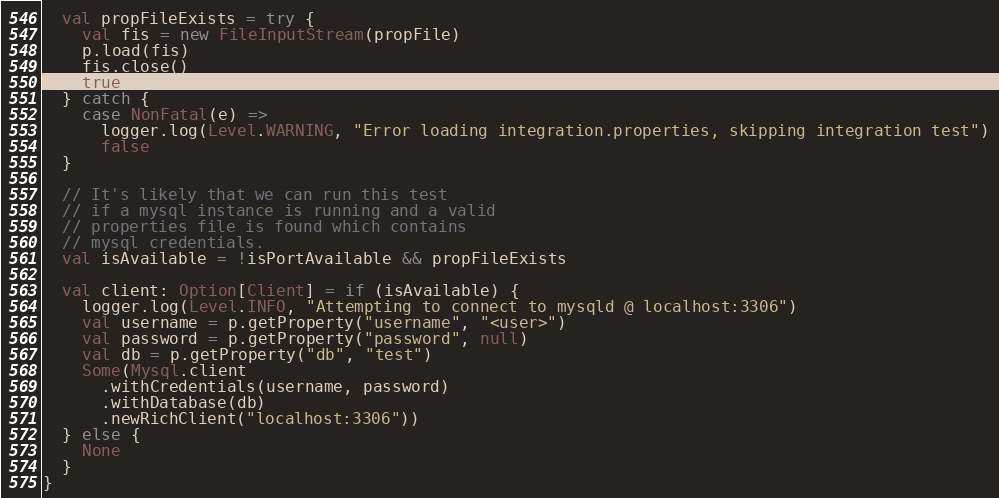<code> <loc_0><loc_0><loc_500><loc_500><_Scala_>  val propFileExists = try {
    val fis = new FileInputStream(propFile)
    p.load(fis)
    fis.close()
    true
  } catch {
    case NonFatal(e) =>
      logger.log(Level.WARNING, "Error loading integration.properties, skipping integration test")
      false
  }

  // It's likely that we can run this test
  // if a mysql instance is running and a valid
  // properties file is found which contains
  // mysql credentials.
  val isAvailable = !isPortAvailable && propFileExists

  val client: Option[Client] = if (isAvailable) {
    logger.log(Level.INFO, "Attempting to connect to mysqld @ localhost:3306")
    val username = p.getProperty("username", "<user>")
    val password = p.getProperty("password", null)
    val db = p.getProperty("db", "test")
    Some(Mysql.client
      .withCredentials(username, password)
      .withDatabase(db)
      .newRichClient("localhost:3306"))
  } else {
    None
  }
}
</code> 